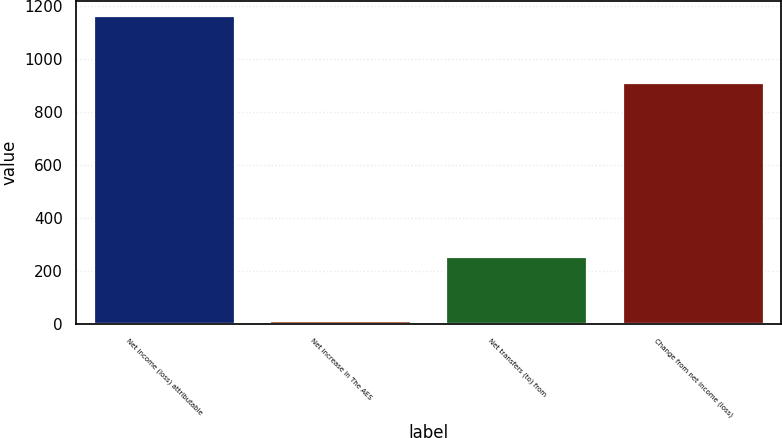<chart> <loc_0><loc_0><loc_500><loc_500><bar_chart><fcel>Net income (loss) attributable<fcel>Net increase in The AES<fcel>Net transfers (to) from<fcel>Change from net income (loss)<nl><fcel>1161<fcel>13<fcel>253<fcel>908<nl></chart> 